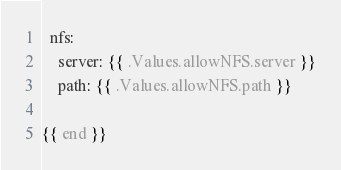Convert code to text. <code><loc_0><loc_0><loc_500><loc_500><_YAML_>  nfs:
    server: {{ .Values.allowNFS.server }}
    path: {{ .Values.allowNFS.path }}

{{ end }}</code> 